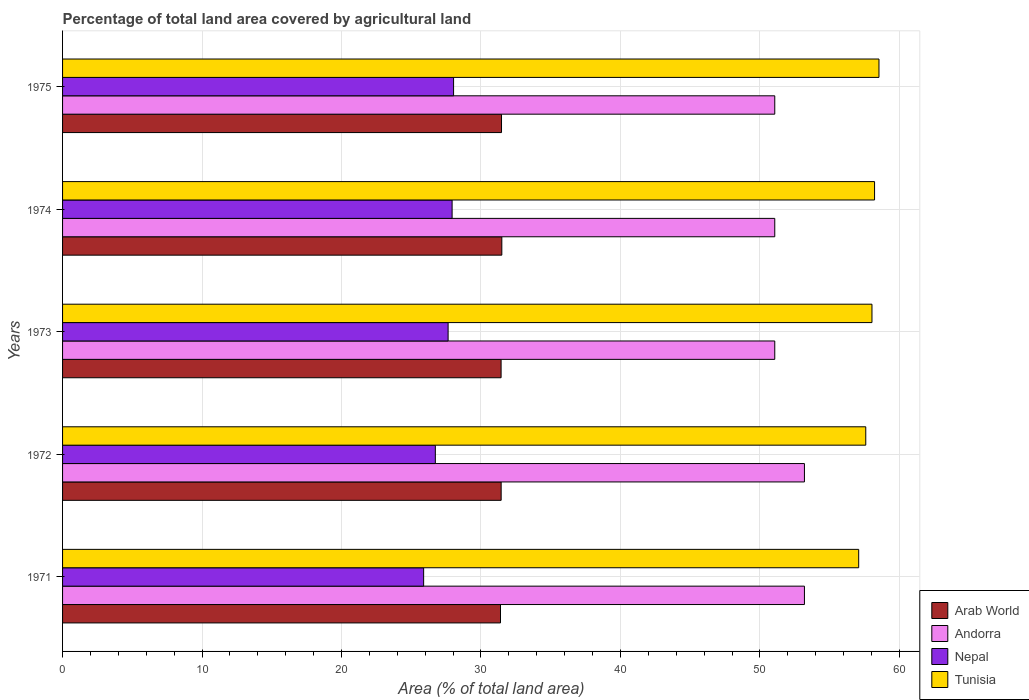How many different coloured bars are there?
Provide a succinct answer. 4. How many groups of bars are there?
Provide a succinct answer. 5. How many bars are there on the 5th tick from the bottom?
Your response must be concise. 4. What is the label of the 1st group of bars from the top?
Offer a very short reply. 1975. In how many cases, is the number of bars for a given year not equal to the number of legend labels?
Your answer should be very brief. 0. What is the percentage of agricultural land in Andorra in 1975?
Ensure brevity in your answer.  51.06. Across all years, what is the maximum percentage of agricultural land in Arab World?
Provide a short and direct response. 31.49. Across all years, what is the minimum percentage of agricultural land in Andorra?
Your answer should be very brief. 51.06. In which year was the percentage of agricultural land in Tunisia maximum?
Keep it short and to the point. 1975. What is the total percentage of agricultural land in Tunisia in the graph?
Provide a short and direct response. 289.46. What is the difference between the percentage of agricultural land in Arab World in 1971 and that in 1974?
Your answer should be very brief. -0.1. What is the difference between the percentage of agricultural land in Andorra in 1971 and the percentage of agricultural land in Tunisia in 1975?
Keep it short and to the point. -5.34. What is the average percentage of agricultural land in Arab World per year?
Your answer should be compact. 31.45. In the year 1972, what is the difference between the percentage of agricultural land in Nepal and percentage of agricultural land in Tunisia?
Offer a terse response. -30.86. What is the ratio of the percentage of agricultural land in Nepal in 1971 to that in 1975?
Your answer should be very brief. 0.92. Is the percentage of agricultural land in Arab World in 1972 less than that in 1974?
Make the answer very short. Yes. Is the difference between the percentage of agricultural land in Nepal in 1973 and 1974 greater than the difference between the percentage of agricultural land in Tunisia in 1973 and 1974?
Provide a succinct answer. No. What is the difference between the highest and the second highest percentage of agricultural land in Tunisia?
Give a very brief answer. 0.32. What is the difference between the highest and the lowest percentage of agricultural land in Tunisia?
Offer a terse response. 1.45. In how many years, is the percentage of agricultural land in Andorra greater than the average percentage of agricultural land in Andorra taken over all years?
Make the answer very short. 2. What does the 4th bar from the top in 1975 represents?
Offer a very short reply. Arab World. What does the 1st bar from the bottom in 1974 represents?
Give a very brief answer. Arab World. Is it the case that in every year, the sum of the percentage of agricultural land in Tunisia and percentage of agricultural land in Nepal is greater than the percentage of agricultural land in Arab World?
Make the answer very short. Yes. How many bars are there?
Give a very brief answer. 20. Are all the bars in the graph horizontal?
Offer a terse response. Yes. Are the values on the major ticks of X-axis written in scientific E-notation?
Give a very brief answer. No. How many legend labels are there?
Keep it short and to the point. 4. What is the title of the graph?
Offer a terse response. Percentage of total land area covered by agricultural land. Does "High income: nonOECD" appear as one of the legend labels in the graph?
Your response must be concise. No. What is the label or title of the X-axis?
Provide a succinct answer. Area (% of total land area). What is the Area (% of total land area) in Arab World in 1971?
Offer a very short reply. 31.4. What is the Area (% of total land area) in Andorra in 1971?
Your response must be concise. 53.19. What is the Area (% of total land area) in Nepal in 1971?
Provide a succinct answer. 25.89. What is the Area (% of total land area) in Tunisia in 1971?
Make the answer very short. 57.08. What is the Area (% of total land area) in Arab World in 1972?
Provide a short and direct response. 31.45. What is the Area (% of total land area) of Andorra in 1972?
Provide a succinct answer. 53.19. What is the Area (% of total land area) of Nepal in 1972?
Keep it short and to the point. 26.73. What is the Area (% of total land area) of Tunisia in 1972?
Ensure brevity in your answer.  57.59. What is the Area (% of total land area) of Arab World in 1973?
Your response must be concise. 31.44. What is the Area (% of total land area) of Andorra in 1973?
Give a very brief answer. 51.06. What is the Area (% of total land area) of Nepal in 1973?
Offer a terse response. 27.64. What is the Area (% of total land area) in Tunisia in 1973?
Offer a very short reply. 58.03. What is the Area (% of total land area) of Arab World in 1974?
Provide a short and direct response. 31.49. What is the Area (% of total land area) in Andorra in 1974?
Make the answer very short. 51.06. What is the Area (% of total land area) in Nepal in 1974?
Give a very brief answer. 27.93. What is the Area (% of total land area) of Tunisia in 1974?
Provide a short and direct response. 58.22. What is the Area (% of total land area) of Arab World in 1975?
Provide a short and direct response. 31.47. What is the Area (% of total land area) in Andorra in 1975?
Make the answer very short. 51.06. What is the Area (% of total land area) in Nepal in 1975?
Offer a terse response. 28.03. What is the Area (% of total land area) in Tunisia in 1975?
Provide a short and direct response. 58.54. Across all years, what is the maximum Area (% of total land area) in Arab World?
Your answer should be very brief. 31.49. Across all years, what is the maximum Area (% of total land area) in Andorra?
Ensure brevity in your answer.  53.19. Across all years, what is the maximum Area (% of total land area) in Nepal?
Provide a succinct answer. 28.03. Across all years, what is the maximum Area (% of total land area) in Tunisia?
Your answer should be compact. 58.54. Across all years, what is the minimum Area (% of total land area) in Arab World?
Your answer should be very brief. 31.4. Across all years, what is the minimum Area (% of total land area) in Andorra?
Keep it short and to the point. 51.06. Across all years, what is the minimum Area (% of total land area) in Nepal?
Your answer should be very brief. 25.89. Across all years, what is the minimum Area (% of total land area) of Tunisia?
Ensure brevity in your answer.  57.08. What is the total Area (% of total land area) in Arab World in the graph?
Give a very brief answer. 157.26. What is the total Area (% of total land area) in Andorra in the graph?
Provide a short and direct response. 259.57. What is the total Area (% of total land area) in Nepal in the graph?
Your answer should be compact. 136.22. What is the total Area (% of total land area) of Tunisia in the graph?
Ensure brevity in your answer.  289.46. What is the difference between the Area (% of total land area) of Arab World in 1971 and that in 1972?
Your response must be concise. -0.05. What is the difference between the Area (% of total land area) of Andorra in 1971 and that in 1972?
Provide a short and direct response. 0. What is the difference between the Area (% of total land area) of Nepal in 1971 and that in 1972?
Ensure brevity in your answer.  -0.84. What is the difference between the Area (% of total land area) in Tunisia in 1971 and that in 1972?
Ensure brevity in your answer.  -0.51. What is the difference between the Area (% of total land area) of Arab World in 1971 and that in 1973?
Ensure brevity in your answer.  -0.04. What is the difference between the Area (% of total land area) in Andorra in 1971 and that in 1973?
Provide a short and direct response. 2.13. What is the difference between the Area (% of total land area) in Nepal in 1971 and that in 1973?
Keep it short and to the point. -1.76. What is the difference between the Area (% of total land area) in Tunisia in 1971 and that in 1973?
Your answer should be compact. -0.95. What is the difference between the Area (% of total land area) in Arab World in 1971 and that in 1974?
Offer a terse response. -0.1. What is the difference between the Area (% of total land area) of Andorra in 1971 and that in 1974?
Provide a succinct answer. 2.13. What is the difference between the Area (% of total land area) in Nepal in 1971 and that in 1974?
Your answer should be very brief. -2.04. What is the difference between the Area (% of total land area) of Tunisia in 1971 and that in 1974?
Your response must be concise. -1.14. What is the difference between the Area (% of total land area) of Arab World in 1971 and that in 1975?
Your answer should be very brief. -0.07. What is the difference between the Area (% of total land area) in Andorra in 1971 and that in 1975?
Your answer should be very brief. 2.13. What is the difference between the Area (% of total land area) of Nepal in 1971 and that in 1975?
Your response must be concise. -2.15. What is the difference between the Area (% of total land area) in Tunisia in 1971 and that in 1975?
Provide a short and direct response. -1.45. What is the difference between the Area (% of total land area) in Arab World in 1972 and that in 1973?
Your answer should be very brief. 0. What is the difference between the Area (% of total land area) of Andorra in 1972 and that in 1973?
Make the answer very short. 2.13. What is the difference between the Area (% of total land area) in Nepal in 1972 and that in 1973?
Your answer should be compact. -0.92. What is the difference between the Area (% of total land area) in Tunisia in 1972 and that in 1973?
Your response must be concise. -0.44. What is the difference between the Area (% of total land area) in Arab World in 1972 and that in 1974?
Provide a succinct answer. -0.05. What is the difference between the Area (% of total land area) in Andorra in 1972 and that in 1974?
Offer a very short reply. 2.13. What is the difference between the Area (% of total land area) of Nepal in 1972 and that in 1974?
Make the answer very short. -1.2. What is the difference between the Area (% of total land area) of Tunisia in 1972 and that in 1974?
Your response must be concise. -0.63. What is the difference between the Area (% of total land area) in Arab World in 1972 and that in 1975?
Offer a very short reply. -0.03. What is the difference between the Area (% of total land area) in Andorra in 1972 and that in 1975?
Your answer should be compact. 2.13. What is the difference between the Area (% of total land area) of Nepal in 1972 and that in 1975?
Give a very brief answer. -1.31. What is the difference between the Area (% of total land area) in Tunisia in 1972 and that in 1975?
Your response must be concise. -0.95. What is the difference between the Area (% of total land area) of Arab World in 1973 and that in 1974?
Give a very brief answer. -0.05. What is the difference between the Area (% of total land area) of Nepal in 1973 and that in 1974?
Ensure brevity in your answer.  -0.29. What is the difference between the Area (% of total land area) in Tunisia in 1973 and that in 1974?
Offer a terse response. -0.19. What is the difference between the Area (% of total land area) of Arab World in 1973 and that in 1975?
Ensure brevity in your answer.  -0.03. What is the difference between the Area (% of total land area) in Andorra in 1973 and that in 1975?
Provide a short and direct response. 0. What is the difference between the Area (% of total land area) in Nepal in 1973 and that in 1975?
Offer a terse response. -0.39. What is the difference between the Area (% of total land area) in Tunisia in 1973 and that in 1975?
Offer a terse response. -0.5. What is the difference between the Area (% of total land area) in Arab World in 1974 and that in 1975?
Make the answer very short. 0.02. What is the difference between the Area (% of total land area) in Andorra in 1974 and that in 1975?
Ensure brevity in your answer.  0. What is the difference between the Area (% of total land area) of Nepal in 1974 and that in 1975?
Provide a short and direct response. -0.1. What is the difference between the Area (% of total land area) of Tunisia in 1974 and that in 1975?
Your response must be concise. -0.32. What is the difference between the Area (% of total land area) of Arab World in 1971 and the Area (% of total land area) of Andorra in 1972?
Make the answer very short. -21.79. What is the difference between the Area (% of total land area) in Arab World in 1971 and the Area (% of total land area) in Nepal in 1972?
Make the answer very short. 4.67. What is the difference between the Area (% of total land area) in Arab World in 1971 and the Area (% of total land area) in Tunisia in 1972?
Provide a short and direct response. -26.19. What is the difference between the Area (% of total land area) of Andorra in 1971 and the Area (% of total land area) of Nepal in 1972?
Provide a short and direct response. 26.46. What is the difference between the Area (% of total land area) in Andorra in 1971 and the Area (% of total land area) in Tunisia in 1972?
Keep it short and to the point. -4.4. What is the difference between the Area (% of total land area) of Nepal in 1971 and the Area (% of total land area) of Tunisia in 1972?
Provide a short and direct response. -31.7. What is the difference between the Area (% of total land area) of Arab World in 1971 and the Area (% of total land area) of Andorra in 1973?
Keep it short and to the point. -19.66. What is the difference between the Area (% of total land area) in Arab World in 1971 and the Area (% of total land area) in Nepal in 1973?
Offer a very short reply. 3.76. What is the difference between the Area (% of total land area) in Arab World in 1971 and the Area (% of total land area) in Tunisia in 1973?
Give a very brief answer. -26.63. What is the difference between the Area (% of total land area) in Andorra in 1971 and the Area (% of total land area) in Nepal in 1973?
Keep it short and to the point. 25.55. What is the difference between the Area (% of total land area) of Andorra in 1971 and the Area (% of total land area) of Tunisia in 1973?
Provide a short and direct response. -4.84. What is the difference between the Area (% of total land area) in Nepal in 1971 and the Area (% of total land area) in Tunisia in 1973?
Offer a terse response. -32.14. What is the difference between the Area (% of total land area) in Arab World in 1971 and the Area (% of total land area) in Andorra in 1974?
Your answer should be compact. -19.66. What is the difference between the Area (% of total land area) in Arab World in 1971 and the Area (% of total land area) in Nepal in 1974?
Your response must be concise. 3.47. What is the difference between the Area (% of total land area) in Arab World in 1971 and the Area (% of total land area) in Tunisia in 1974?
Your response must be concise. -26.82. What is the difference between the Area (% of total land area) of Andorra in 1971 and the Area (% of total land area) of Nepal in 1974?
Your answer should be compact. 25.26. What is the difference between the Area (% of total land area) of Andorra in 1971 and the Area (% of total land area) of Tunisia in 1974?
Your response must be concise. -5.03. What is the difference between the Area (% of total land area) of Nepal in 1971 and the Area (% of total land area) of Tunisia in 1974?
Offer a very short reply. -32.33. What is the difference between the Area (% of total land area) in Arab World in 1971 and the Area (% of total land area) in Andorra in 1975?
Ensure brevity in your answer.  -19.66. What is the difference between the Area (% of total land area) of Arab World in 1971 and the Area (% of total land area) of Nepal in 1975?
Ensure brevity in your answer.  3.36. What is the difference between the Area (% of total land area) of Arab World in 1971 and the Area (% of total land area) of Tunisia in 1975?
Offer a terse response. -27.14. What is the difference between the Area (% of total land area) of Andorra in 1971 and the Area (% of total land area) of Nepal in 1975?
Offer a terse response. 25.16. What is the difference between the Area (% of total land area) of Andorra in 1971 and the Area (% of total land area) of Tunisia in 1975?
Your response must be concise. -5.34. What is the difference between the Area (% of total land area) of Nepal in 1971 and the Area (% of total land area) of Tunisia in 1975?
Ensure brevity in your answer.  -32.65. What is the difference between the Area (% of total land area) in Arab World in 1972 and the Area (% of total land area) in Andorra in 1973?
Provide a short and direct response. -19.62. What is the difference between the Area (% of total land area) of Arab World in 1972 and the Area (% of total land area) of Nepal in 1973?
Offer a terse response. 3.8. What is the difference between the Area (% of total land area) in Arab World in 1972 and the Area (% of total land area) in Tunisia in 1973?
Keep it short and to the point. -26.59. What is the difference between the Area (% of total land area) of Andorra in 1972 and the Area (% of total land area) of Nepal in 1973?
Your response must be concise. 25.55. What is the difference between the Area (% of total land area) of Andorra in 1972 and the Area (% of total land area) of Tunisia in 1973?
Your response must be concise. -4.84. What is the difference between the Area (% of total land area) of Nepal in 1972 and the Area (% of total land area) of Tunisia in 1973?
Provide a short and direct response. -31.31. What is the difference between the Area (% of total land area) of Arab World in 1972 and the Area (% of total land area) of Andorra in 1974?
Keep it short and to the point. -19.62. What is the difference between the Area (% of total land area) of Arab World in 1972 and the Area (% of total land area) of Nepal in 1974?
Ensure brevity in your answer.  3.52. What is the difference between the Area (% of total land area) in Arab World in 1972 and the Area (% of total land area) in Tunisia in 1974?
Keep it short and to the point. -26.77. What is the difference between the Area (% of total land area) of Andorra in 1972 and the Area (% of total land area) of Nepal in 1974?
Offer a terse response. 25.26. What is the difference between the Area (% of total land area) of Andorra in 1972 and the Area (% of total land area) of Tunisia in 1974?
Offer a very short reply. -5.03. What is the difference between the Area (% of total land area) in Nepal in 1972 and the Area (% of total land area) in Tunisia in 1974?
Offer a very short reply. -31.49. What is the difference between the Area (% of total land area) of Arab World in 1972 and the Area (% of total land area) of Andorra in 1975?
Your response must be concise. -19.62. What is the difference between the Area (% of total land area) in Arab World in 1972 and the Area (% of total land area) in Nepal in 1975?
Provide a short and direct response. 3.41. What is the difference between the Area (% of total land area) of Arab World in 1972 and the Area (% of total land area) of Tunisia in 1975?
Give a very brief answer. -27.09. What is the difference between the Area (% of total land area) of Andorra in 1972 and the Area (% of total land area) of Nepal in 1975?
Your answer should be compact. 25.16. What is the difference between the Area (% of total land area) in Andorra in 1972 and the Area (% of total land area) in Tunisia in 1975?
Make the answer very short. -5.34. What is the difference between the Area (% of total land area) in Nepal in 1972 and the Area (% of total land area) in Tunisia in 1975?
Your answer should be very brief. -31.81. What is the difference between the Area (% of total land area) of Arab World in 1973 and the Area (% of total land area) of Andorra in 1974?
Make the answer very short. -19.62. What is the difference between the Area (% of total land area) of Arab World in 1973 and the Area (% of total land area) of Nepal in 1974?
Keep it short and to the point. 3.51. What is the difference between the Area (% of total land area) of Arab World in 1973 and the Area (% of total land area) of Tunisia in 1974?
Your answer should be very brief. -26.78. What is the difference between the Area (% of total land area) of Andorra in 1973 and the Area (% of total land area) of Nepal in 1974?
Your response must be concise. 23.13. What is the difference between the Area (% of total land area) in Andorra in 1973 and the Area (% of total land area) in Tunisia in 1974?
Keep it short and to the point. -7.16. What is the difference between the Area (% of total land area) of Nepal in 1973 and the Area (% of total land area) of Tunisia in 1974?
Your response must be concise. -30.58. What is the difference between the Area (% of total land area) of Arab World in 1973 and the Area (% of total land area) of Andorra in 1975?
Your answer should be compact. -19.62. What is the difference between the Area (% of total land area) of Arab World in 1973 and the Area (% of total land area) of Nepal in 1975?
Provide a short and direct response. 3.41. What is the difference between the Area (% of total land area) in Arab World in 1973 and the Area (% of total land area) in Tunisia in 1975?
Provide a short and direct response. -27.09. What is the difference between the Area (% of total land area) of Andorra in 1973 and the Area (% of total land area) of Nepal in 1975?
Provide a succinct answer. 23.03. What is the difference between the Area (% of total land area) of Andorra in 1973 and the Area (% of total land area) of Tunisia in 1975?
Your answer should be compact. -7.47. What is the difference between the Area (% of total land area) in Nepal in 1973 and the Area (% of total land area) in Tunisia in 1975?
Provide a short and direct response. -30.89. What is the difference between the Area (% of total land area) of Arab World in 1974 and the Area (% of total land area) of Andorra in 1975?
Your answer should be very brief. -19.57. What is the difference between the Area (% of total land area) in Arab World in 1974 and the Area (% of total land area) in Nepal in 1975?
Offer a very short reply. 3.46. What is the difference between the Area (% of total land area) in Arab World in 1974 and the Area (% of total land area) in Tunisia in 1975?
Ensure brevity in your answer.  -27.04. What is the difference between the Area (% of total land area) in Andorra in 1974 and the Area (% of total land area) in Nepal in 1975?
Keep it short and to the point. 23.03. What is the difference between the Area (% of total land area) of Andorra in 1974 and the Area (% of total land area) of Tunisia in 1975?
Your answer should be compact. -7.47. What is the difference between the Area (% of total land area) in Nepal in 1974 and the Area (% of total land area) in Tunisia in 1975?
Give a very brief answer. -30.6. What is the average Area (% of total land area) in Arab World per year?
Provide a short and direct response. 31.45. What is the average Area (% of total land area) of Andorra per year?
Ensure brevity in your answer.  51.91. What is the average Area (% of total land area) in Nepal per year?
Provide a succinct answer. 27.24. What is the average Area (% of total land area) in Tunisia per year?
Your answer should be compact. 57.89. In the year 1971, what is the difference between the Area (% of total land area) of Arab World and Area (% of total land area) of Andorra?
Your answer should be compact. -21.79. In the year 1971, what is the difference between the Area (% of total land area) in Arab World and Area (% of total land area) in Nepal?
Offer a terse response. 5.51. In the year 1971, what is the difference between the Area (% of total land area) of Arab World and Area (% of total land area) of Tunisia?
Offer a very short reply. -25.68. In the year 1971, what is the difference between the Area (% of total land area) in Andorra and Area (% of total land area) in Nepal?
Your response must be concise. 27.3. In the year 1971, what is the difference between the Area (% of total land area) in Andorra and Area (% of total land area) in Tunisia?
Give a very brief answer. -3.89. In the year 1971, what is the difference between the Area (% of total land area) of Nepal and Area (% of total land area) of Tunisia?
Offer a very short reply. -31.19. In the year 1972, what is the difference between the Area (% of total land area) in Arab World and Area (% of total land area) in Andorra?
Ensure brevity in your answer.  -21.74. In the year 1972, what is the difference between the Area (% of total land area) in Arab World and Area (% of total land area) in Nepal?
Your answer should be compact. 4.72. In the year 1972, what is the difference between the Area (% of total land area) in Arab World and Area (% of total land area) in Tunisia?
Give a very brief answer. -26.14. In the year 1972, what is the difference between the Area (% of total land area) in Andorra and Area (% of total land area) in Nepal?
Your answer should be compact. 26.46. In the year 1972, what is the difference between the Area (% of total land area) of Andorra and Area (% of total land area) of Tunisia?
Offer a very short reply. -4.4. In the year 1972, what is the difference between the Area (% of total land area) in Nepal and Area (% of total land area) in Tunisia?
Your response must be concise. -30.86. In the year 1973, what is the difference between the Area (% of total land area) of Arab World and Area (% of total land area) of Andorra?
Provide a succinct answer. -19.62. In the year 1973, what is the difference between the Area (% of total land area) in Arab World and Area (% of total land area) in Nepal?
Ensure brevity in your answer.  3.8. In the year 1973, what is the difference between the Area (% of total land area) in Arab World and Area (% of total land area) in Tunisia?
Keep it short and to the point. -26.59. In the year 1973, what is the difference between the Area (% of total land area) in Andorra and Area (% of total land area) in Nepal?
Offer a very short reply. 23.42. In the year 1973, what is the difference between the Area (% of total land area) in Andorra and Area (% of total land area) in Tunisia?
Ensure brevity in your answer.  -6.97. In the year 1973, what is the difference between the Area (% of total land area) of Nepal and Area (% of total land area) of Tunisia?
Give a very brief answer. -30.39. In the year 1974, what is the difference between the Area (% of total land area) in Arab World and Area (% of total land area) in Andorra?
Keep it short and to the point. -19.57. In the year 1974, what is the difference between the Area (% of total land area) of Arab World and Area (% of total land area) of Nepal?
Provide a succinct answer. 3.56. In the year 1974, what is the difference between the Area (% of total land area) in Arab World and Area (% of total land area) in Tunisia?
Make the answer very short. -26.72. In the year 1974, what is the difference between the Area (% of total land area) in Andorra and Area (% of total land area) in Nepal?
Your answer should be compact. 23.13. In the year 1974, what is the difference between the Area (% of total land area) in Andorra and Area (% of total land area) in Tunisia?
Your answer should be very brief. -7.16. In the year 1974, what is the difference between the Area (% of total land area) of Nepal and Area (% of total land area) of Tunisia?
Provide a short and direct response. -30.29. In the year 1975, what is the difference between the Area (% of total land area) of Arab World and Area (% of total land area) of Andorra?
Your answer should be compact. -19.59. In the year 1975, what is the difference between the Area (% of total land area) of Arab World and Area (% of total land area) of Nepal?
Your response must be concise. 3.44. In the year 1975, what is the difference between the Area (% of total land area) in Arab World and Area (% of total land area) in Tunisia?
Make the answer very short. -27.06. In the year 1975, what is the difference between the Area (% of total land area) in Andorra and Area (% of total land area) in Nepal?
Offer a very short reply. 23.03. In the year 1975, what is the difference between the Area (% of total land area) in Andorra and Area (% of total land area) in Tunisia?
Give a very brief answer. -7.47. In the year 1975, what is the difference between the Area (% of total land area) of Nepal and Area (% of total land area) of Tunisia?
Make the answer very short. -30.5. What is the ratio of the Area (% of total land area) of Arab World in 1971 to that in 1972?
Make the answer very short. 1. What is the ratio of the Area (% of total land area) in Nepal in 1971 to that in 1972?
Provide a succinct answer. 0.97. What is the ratio of the Area (% of total land area) of Tunisia in 1971 to that in 1972?
Make the answer very short. 0.99. What is the ratio of the Area (% of total land area) in Andorra in 1971 to that in 1973?
Provide a succinct answer. 1.04. What is the ratio of the Area (% of total land area) in Nepal in 1971 to that in 1973?
Your answer should be very brief. 0.94. What is the ratio of the Area (% of total land area) of Tunisia in 1971 to that in 1973?
Your answer should be compact. 0.98. What is the ratio of the Area (% of total land area) of Andorra in 1971 to that in 1974?
Your answer should be very brief. 1.04. What is the ratio of the Area (% of total land area) in Nepal in 1971 to that in 1974?
Give a very brief answer. 0.93. What is the ratio of the Area (% of total land area) in Tunisia in 1971 to that in 1974?
Provide a short and direct response. 0.98. What is the ratio of the Area (% of total land area) in Andorra in 1971 to that in 1975?
Your answer should be very brief. 1.04. What is the ratio of the Area (% of total land area) of Nepal in 1971 to that in 1975?
Make the answer very short. 0.92. What is the ratio of the Area (% of total land area) of Tunisia in 1971 to that in 1975?
Your answer should be compact. 0.98. What is the ratio of the Area (% of total land area) of Arab World in 1972 to that in 1973?
Provide a short and direct response. 1. What is the ratio of the Area (% of total land area) in Andorra in 1972 to that in 1973?
Your answer should be very brief. 1.04. What is the ratio of the Area (% of total land area) in Nepal in 1972 to that in 1973?
Give a very brief answer. 0.97. What is the ratio of the Area (% of total land area) of Tunisia in 1972 to that in 1973?
Your answer should be compact. 0.99. What is the ratio of the Area (% of total land area) in Andorra in 1972 to that in 1974?
Ensure brevity in your answer.  1.04. What is the ratio of the Area (% of total land area) in Nepal in 1972 to that in 1974?
Provide a short and direct response. 0.96. What is the ratio of the Area (% of total land area) of Arab World in 1972 to that in 1975?
Your response must be concise. 1. What is the ratio of the Area (% of total land area) of Andorra in 1972 to that in 1975?
Offer a terse response. 1.04. What is the ratio of the Area (% of total land area) of Nepal in 1972 to that in 1975?
Offer a terse response. 0.95. What is the ratio of the Area (% of total land area) in Tunisia in 1972 to that in 1975?
Provide a succinct answer. 0.98. What is the ratio of the Area (% of total land area) in Andorra in 1973 to that in 1974?
Your answer should be compact. 1. What is the ratio of the Area (% of total land area) in Tunisia in 1973 to that in 1974?
Offer a terse response. 1. What is the ratio of the Area (% of total land area) in Arab World in 1973 to that in 1975?
Keep it short and to the point. 1. What is the ratio of the Area (% of total land area) in Andorra in 1973 to that in 1975?
Your answer should be compact. 1. What is the ratio of the Area (% of total land area) in Nepal in 1973 to that in 1975?
Give a very brief answer. 0.99. What is the ratio of the Area (% of total land area) of Tunisia in 1973 to that in 1975?
Your answer should be very brief. 0.99. What is the ratio of the Area (% of total land area) in Nepal in 1974 to that in 1975?
Ensure brevity in your answer.  1. What is the difference between the highest and the second highest Area (% of total land area) in Arab World?
Give a very brief answer. 0.02. What is the difference between the highest and the second highest Area (% of total land area) of Andorra?
Ensure brevity in your answer.  0. What is the difference between the highest and the second highest Area (% of total land area) of Nepal?
Give a very brief answer. 0.1. What is the difference between the highest and the second highest Area (% of total land area) of Tunisia?
Your answer should be very brief. 0.32. What is the difference between the highest and the lowest Area (% of total land area) of Arab World?
Make the answer very short. 0.1. What is the difference between the highest and the lowest Area (% of total land area) of Andorra?
Provide a succinct answer. 2.13. What is the difference between the highest and the lowest Area (% of total land area) in Nepal?
Keep it short and to the point. 2.15. What is the difference between the highest and the lowest Area (% of total land area) of Tunisia?
Provide a succinct answer. 1.45. 